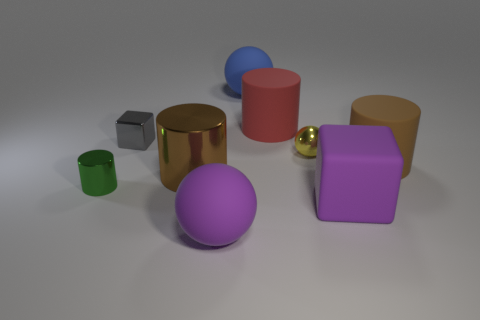There is a rubber thing that is the same color as the big shiny object; what size is it?
Your response must be concise. Large. There is a large object that is the same color as the big metallic cylinder; what is its shape?
Your answer should be very brief. Cylinder. There is a thing that is the same color as the rubber cube; what is its material?
Offer a terse response. Rubber. What number of large rubber objects have the same color as the tiny shiny cube?
Your answer should be very brief. 0. What is the material of the purple object that is on the left side of the big red object that is behind the tiny gray metal thing?
Ensure brevity in your answer.  Rubber. The yellow metal ball has what size?
Keep it short and to the point. Small. What number of gray metal objects are the same size as the metallic cube?
Keep it short and to the point. 0. What number of tiny gray shiny objects have the same shape as the big metallic thing?
Offer a terse response. 0. Are there the same number of brown rubber things that are behind the red thing and green rubber cylinders?
Your response must be concise. Yes. Are there any other things that have the same size as the yellow metallic ball?
Keep it short and to the point. Yes. 